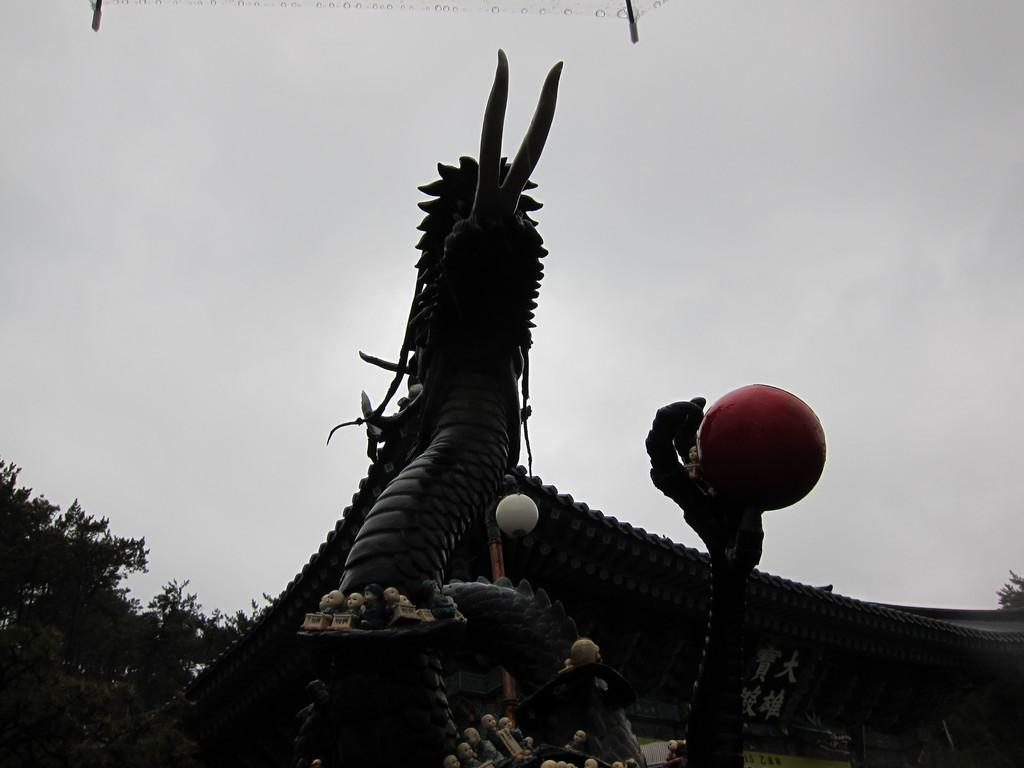What is the main subject of the image? There is a statue of a dragon in the image. Where is the statue located in the image? The statue is located at the bottom of the image. What else can be seen in the bottom left corner of the image? There is a tree in the bottom left corner of the image. What is visible in the background of the image? The sky is visible in the background of the image. What type of hand is holding the bait near the dragon statue in the image? There is no hand or bait present in the image; it only features a statue of a dragon and a tree. Can you see a toad near the tree in the image? There is no toad visible in the image; it only features a statue of a dragon and a tree. 